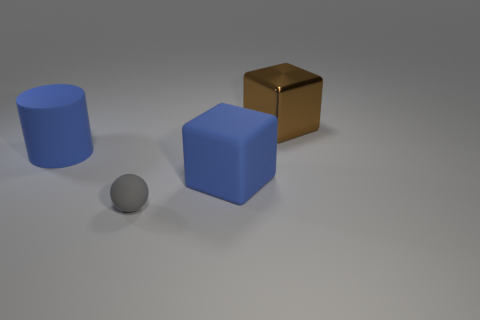How many big objects are either gray rubber things or blue blocks?
Your answer should be very brief. 1. Are there the same number of small things in front of the metal cube and spheres on the left side of the gray ball?
Keep it short and to the point. No. How many other things are there of the same color as the rubber ball?
Your answer should be very brief. 0. Are there an equal number of tiny matte things that are behind the big matte cylinder and tiny rubber cubes?
Your response must be concise. Yes. Does the blue cylinder have the same size as the ball?
Keep it short and to the point. No. What material is the thing that is both in front of the large matte cylinder and right of the small gray rubber ball?
Your response must be concise. Rubber. How many large blue matte objects have the same shape as the big brown metal object?
Your answer should be very brief. 1. There is a big brown block on the right side of the blue cube; what is its material?
Provide a succinct answer. Metal. Is the number of big blue blocks behind the large blue cylinder less than the number of tiny brown shiny balls?
Make the answer very short. No. Does the brown metallic object have the same shape as the gray object?
Offer a very short reply. No. 